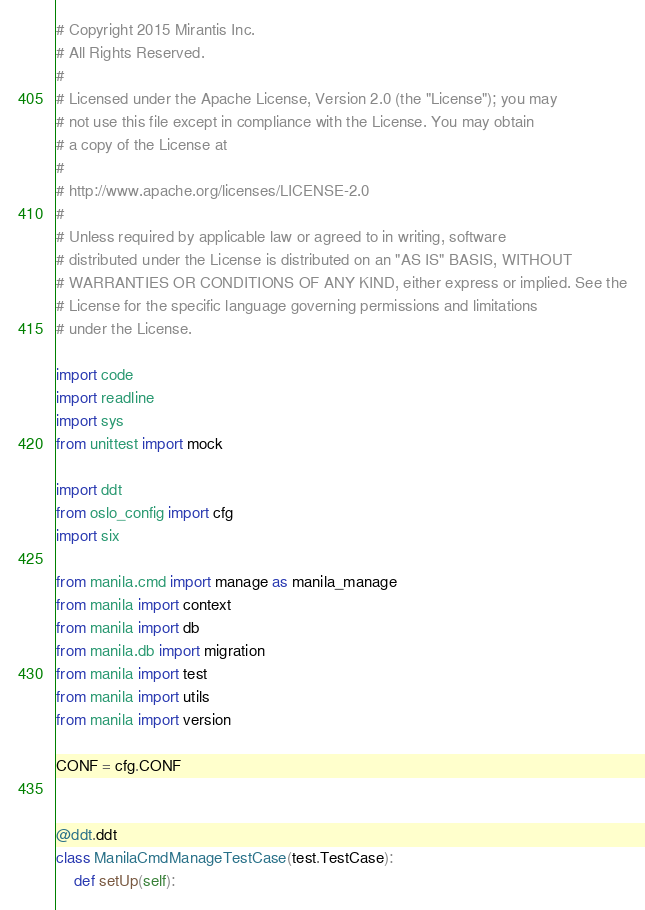<code> <loc_0><loc_0><loc_500><loc_500><_Python_># Copyright 2015 Mirantis Inc.
# All Rights Reserved.
#
# Licensed under the Apache License, Version 2.0 (the "License"); you may
# not use this file except in compliance with the License. You may obtain
# a copy of the License at
#
# http://www.apache.org/licenses/LICENSE-2.0
#
# Unless required by applicable law or agreed to in writing, software
# distributed under the License is distributed on an "AS IS" BASIS, WITHOUT
# WARRANTIES OR CONDITIONS OF ANY KIND, either express or implied. See the
# License for the specific language governing permissions and limitations
# under the License.

import code
import readline
import sys
from unittest import mock

import ddt
from oslo_config import cfg
import six

from manila.cmd import manage as manila_manage
from manila import context
from manila import db
from manila.db import migration
from manila import test
from manila import utils
from manila import version

CONF = cfg.CONF


@ddt.ddt
class ManilaCmdManageTestCase(test.TestCase):
    def setUp(self):</code> 